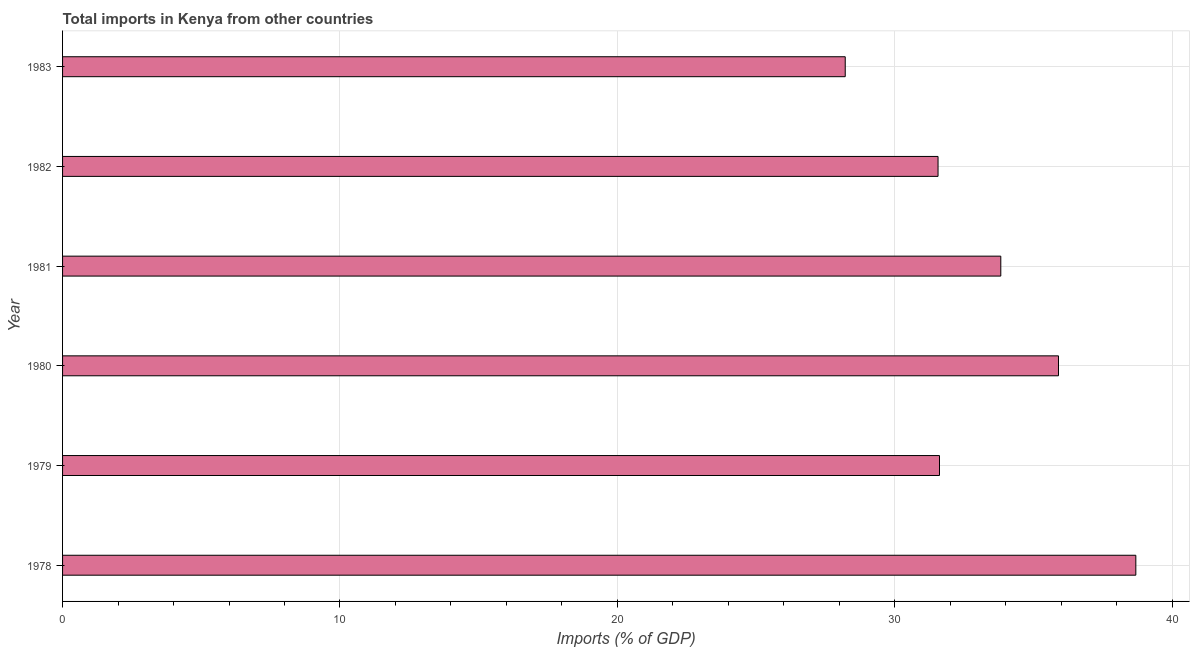Does the graph contain any zero values?
Make the answer very short. No. What is the title of the graph?
Provide a short and direct response. Total imports in Kenya from other countries. What is the label or title of the X-axis?
Ensure brevity in your answer.  Imports (% of GDP). What is the label or title of the Y-axis?
Your response must be concise. Year. What is the total imports in 1980?
Provide a short and direct response. 35.9. Across all years, what is the maximum total imports?
Offer a very short reply. 38.69. Across all years, what is the minimum total imports?
Give a very brief answer. 28.21. In which year was the total imports maximum?
Provide a short and direct response. 1978. What is the sum of the total imports?
Give a very brief answer. 199.79. What is the difference between the total imports in 1978 and 1979?
Ensure brevity in your answer.  7.08. What is the average total imports per year?
Your response must be concise. 33.3. What is the median total imports?
Offer a very short reply. 32.72. In how many years, is the total imports greater than 4 %?
Your answer should be very brief. 6. What is the ratio of the total imports in 1978 to that in 1980?
Give a very brief answer. 1.08. Is the total imports in 1978 less than that in 1979?
Your response must be concise. No. What is the difference between the highest and the second highest total imports?
Your response must be concise. 2.79. Is the sum of the total imports in 1979 and 1981 greater than the maximum total imports across all years?
Your answer should be very brief. Yes. What is the difference between the highest and the lowest total imports?
Your answer should be compact. 10.48. How many bars are there?
Offer a very short reply. 6. Are all the bars in the graph horizontal?
Offer a very short reply. Yes. What is the Imports (% of GDP) of 1978?
Offer a terse response. 38.69. What is the Imports (% of GDP) in 1979?
Offer a terse response. 31.61. What is the Imports (% of GDP) of 1980?
Your response must be concise. 35.9. What is the Imports (% of GDP) in 1981?
Provide a short and direct response. 33.82. What is the Imports (% of GDP) in 1982?
Provide a short and direct response. 31.56. What is the Imports (% of GDP) in 1983?
Your answer should be very brief. 28.21. What is the difference between the Imports (% of GDP) in 1978 and 1979?
Your answer should be compact. 7.08. What is the difference between the Imports (% of GDP) in 1978 and 1980?
Provide a short and direct response. 2.79. What is the difference between the Imports (% of GDP) in 1978 and 1981?
Keep it short and to the point. 4.87. What is the difference between the Imports (% of GDP) in 1978 and 1982?
Make the answer very short. 7.13. What is the difference between the Imports (% of GDP) in 1978 and 1983?
Your answer should be very brief. 10.48. What is the difference between the Imports (% of GDP) in 1979 and 1980?
Offer a very short reply. -4.29. What is the difference between the Imports (% of GDP) in 1979 and 1981?
Give a very brief answer. -2.21. What is the difference between the Imports (% of GDP) in 1979 and 1982?
Your answer should be very brief. 0.05. What is the difference between the Imports (% of GDP) in 1979 and 1983?
Provide a short and direct response. 3.4. What is the difference between the Imports (% of GDP) in 1980 and 1981?
Your answer should be very brief. 2.08. What is the difference between the Imports (% of GDP) in 1980 and 1982?
Make the answer very short. 4.34. What is the difference between the Imports (% of GDP) in 1980 and 1983?
Your answer should be very brief. 7.69. What is the difference between the Imports (% of GDP) in 1981 and 1982?
Provide a succinct answer. 2.26. What is the difference between the Imports (% of GDP) in 1981 and 1983?
Your answer should be compact. 5.61. What is the difference between the Imports (% of GDP) in 1982 and 1983?
Give a very brief answer. 3.35. What is the ratio of the Imports (% of GDP) in 1978 to that in 1979?
Make the answer very short. 1.22. What is the ratio of the Imports (% of GDP) in 1978 to that in 1980?
Make the answer very short. 1.08. What is the ratio of the Imports (% of GDP) in 1978 to that in 1981?
Your answer should be compact. 1.14. What is the ratio of the Imports (% of GDP) in 1978 to that in 1982?
Provide a short and direct response. 1.23. What is the ratio of the Imports (% of GDP) in 1978 to that in 1983?
Provide a short and direct response. 1.37. What is the ratio of the Imports (% of GDP) in 1979 to that in 1980?
Give a very brief answer. 0.88. What is the ratio of the Imports (% of GDP) in 1979 to that in 1981?
Give a very brief answer. 0.94. What is the ratio of the Imports (% of GDP) in 1979 to that in 1983?
Your response must be concise. 1.12. What is the ratio of the Imports (% of GDP) in 1980 to that in 1981?
Offer a terse response. 1.06. What is the ratio of the Imports (% of GDP) in 1980 to that in 1982?
Offer a very short reply. 1.14. What is the ratio of the Imports (% of GDP) in 1980 to that in 1983?
Your answer should be compact. 1.27. What is the ratio of the Imports (% of GDP) in 1981 to that in 1982?
Provide a succinct answer. 1.07. What is the ratio of the Imports (% of GDP) in 1981 to that in 1983?
Your answer should be compact. 1.2. What is the ratio of the Imports (% of GDP) in 1982 to that in 1983?
Give a very brief answer. 1.12. 